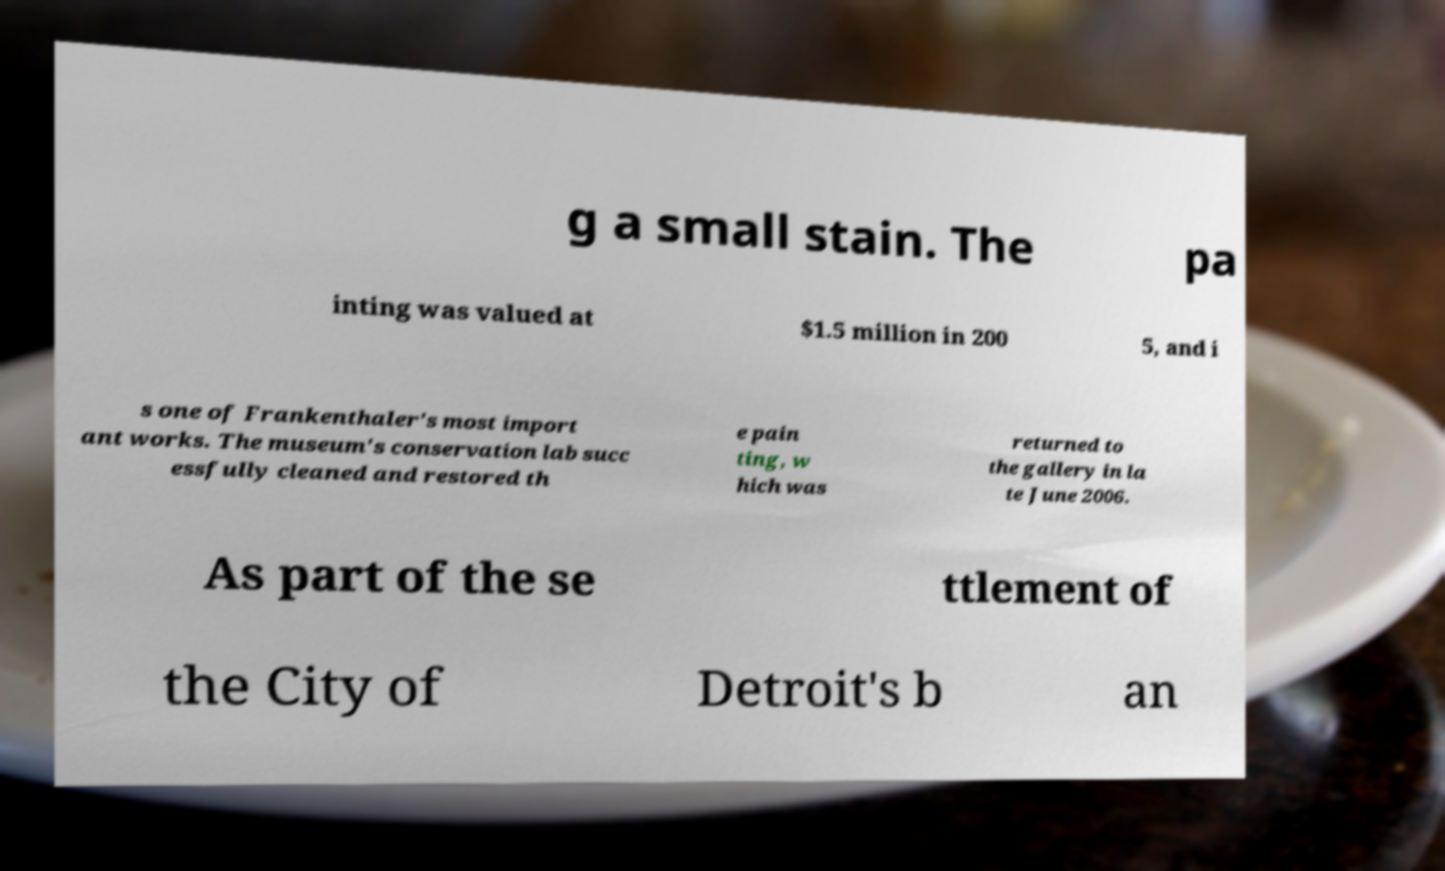Can you accurately transcribe the text from the provided image for me? g a small stain. The pa inting was valued at $1.5 million in 200 5, and i s one of Frankenthaler's most import ant works. The museum's conservation lab succ essfully cleaned and restored th e pain ting, w hich was returned to the gallery in la te June 2006. As part of the se ttlement of the City of Detroit's b an 